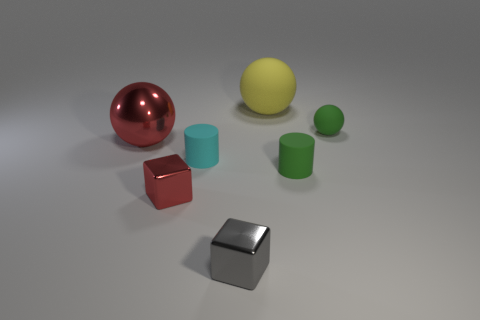Add 3 large cylinders. How many objects exist? 10 Subtract all green spheres. How many spheres are left? 2 Subtract all small green matte balls. How many balls are left? 2 Subtract 0 brown balls. How many objects are left? 7 Subtract all blocks. How many objects are left? 5 Subtract 1 cylinders. How many cylinders are left? 1 Subtract all green cubes. Subtract all brown cylinders. How many cubes are left? 2 Subtract all blue cylinders. How many yellow cubes are left? 0 Subtract all yellow matte things. Subtract all small gray shiny things. How many objects are left? 5 Add 6 tiny blocks. How many tiny blocks are left? 8 